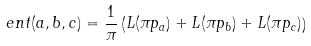<formula> <loc_0><loc_0><loc_500><loc_500>e n t ( a , b , c ) = \frac { 1 } { \pi } \left ( L ( \pi p _ { a } ) + L ( \pi p _ { b } ) + L ( \pi p _ { c } ) \right )</formula> 